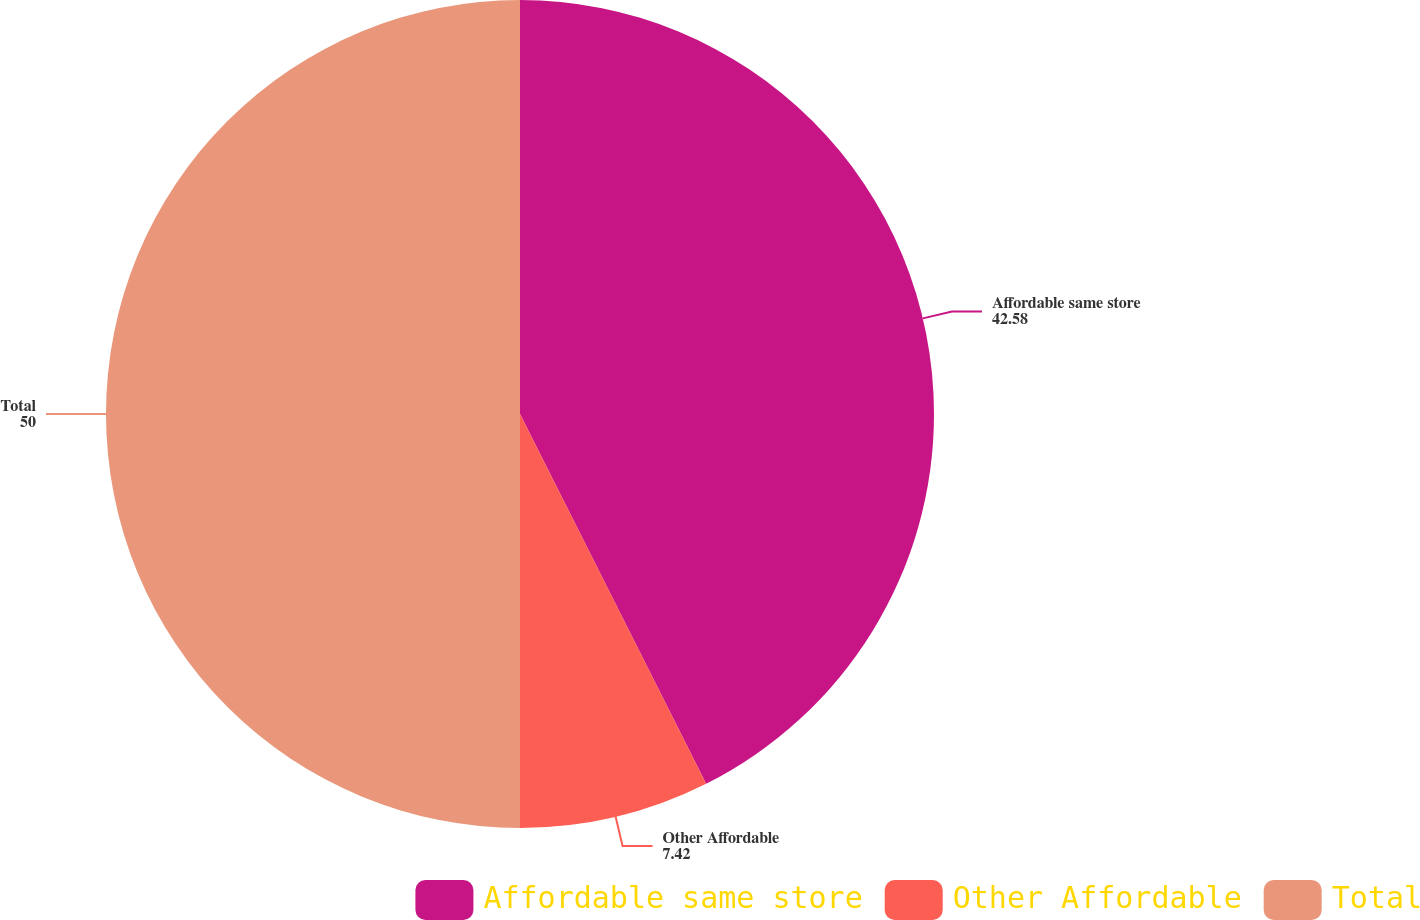Convert chart. <chart><loc_0><loc_0><loc_500><loc_500><pie_chart><fcel>Affordable same store<fcel>Other Affordable<fcel>Total<nl><fcel>42.58%<fcel>7.42%<fcel>50.0%<nl></chart> 